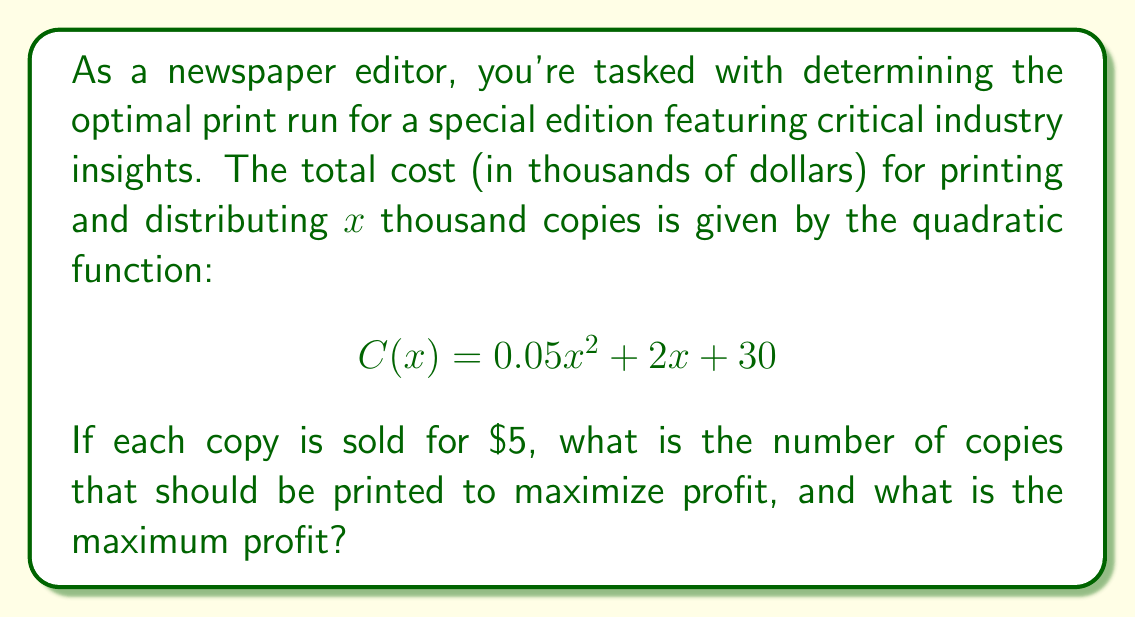Solve this math problem. To solve this problem, we'll follow these steps:

1) First, let's define the revenue function. If each copy is sold for $5, the revenue (in thousands of dollars) is:

   $$ R(x) = 5x $$

2) The profit function P(x) is the difference between revenue and cost:

   $$ P(x) = R(x) - C(x) = 5x - (0.05x^2 + 2x + 30) $$
   $$ P(x) = -0.05x^2 + 3x - 30 $$

3) To find the maximum profit, we need to find the vertex of this parabola. The x-coordinate of the vertex will give us the optimal number of copies to print.

4) For a quadratic function in the form $ax^2 + bx + c$, the x-coordinate of the vertex is given by $-b/(2a)$.

   Here, $a = -0.05$ and $b = 3$

   $$ x = -\frac{3}{2(-0.05)} = \frac{3}{0.1} = 30 $$

5) Therefore, the optimal number of copies to print is 30,000.

6) To find the maximum profit, we substitute x = 30 into the profit function:

   $$ P(30) = -0.05(30)^2 + 3(30) - 30 $$
   $$ = -45 + 90 - 30 = 15 $$

7) The maximum profit is $15,000.
Answer: The optimal number of copies to print is 30,000, and the maximum profit is $15,000. 